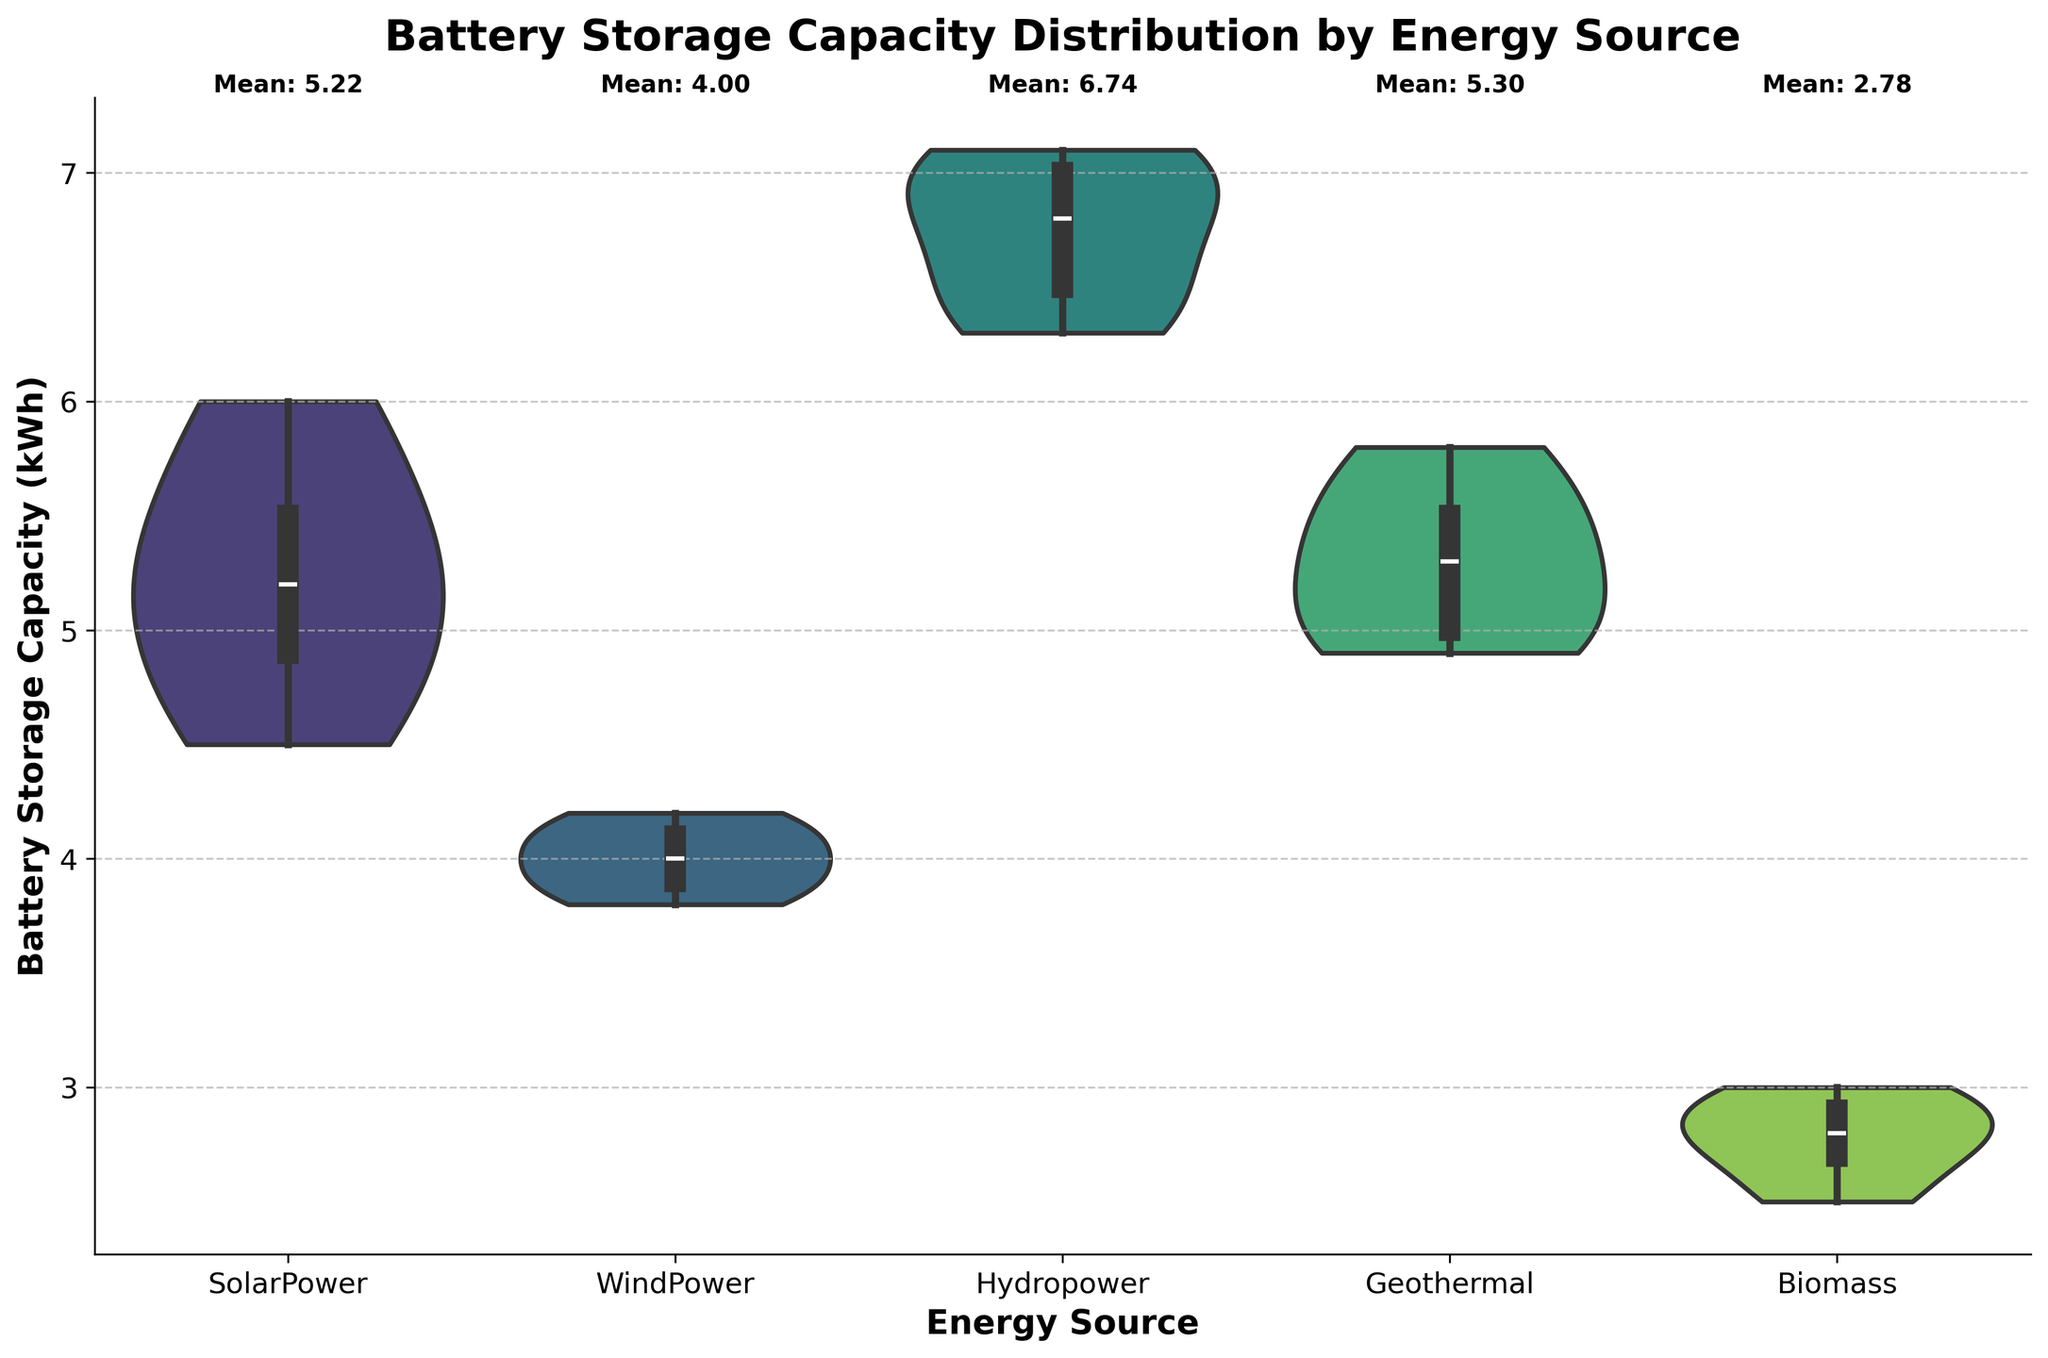What is the title of the figure? The title is usually located at the top center of the figure. For this figure, it reads "Battery Storage Capacity Distribution by Energy Source".
Answer: Battery Storage Capacity Distribution by Energy Source What is the y-axis label? The y-axis label is found on the left side of the figure, describing what is being measured. Here, it is labeled "Battery Storage Capacity (kWh)".
Answer: Battery Storage Capacity (kWh) How many energy sources are compared in the figure? You can count the unique categories on the x-axis to determine the number of energy sources. In this case, there are five distinct sources: SolarPower, WindPower, Hydropower, Geothermal, and Biomass.
Answer: Five Which energy source has the highest mean battery storage capacity? According to the textual annotations at the top of each violion plot, Hydropower has the highest mean value.
Answer: Hydropower Which energy source has the smallest spread in battery storage capacity? The energy source with the smallest spread will have the narrowest violin plot. Biomass has the narrowest spread among all the energy sources.
Answer: Biomass What is the approximate median battery storage capacity for SolarPower? The median is indicated by the white dot inside the violin plot. For SolarPower, this dot appears to be around 5 kWh.
Answer: ~5 kWh Compare the range of battery storage capacities between WindPower and Geothermal. The range is the difference between the maximum and minimum values. WindPower ranges from about 3.8 to 4.2 kWh, while Geothermal ranges from about 4.9 to 5.8 kWh.
Answer: WindPower: 3.8-4.2 kWh, Geothermal: 4.9-5.8 kWh How do the interquartile ranges (IQR) of SolarPower and Hydropower compare? The interquartile range is represented by the width of the middle of the violin plot. SolarPower has a middle width between ~4.8 to 5.5 kWh, while Hydropower spans from ~6.3 to 7.0 kWh.
Answer: SolarPower: ~4.8-5.5 kWh, Hydropower: ~6.3-7.0 kWh Which energy source shows the most symmetrical distribution of battery storage capacities? The most symmetrical violin plot indicates that the data is evenly distributed around the median. Hydropower appears to have the most symmetrical distribution.
Answer: Hydropower What conclusion can you draw about the diversity of battery storage capacities in residential areas across different energy sources? Energy sources like Biomass show very narrow distributions, indicating less diversity in battery capacities, while others like SolarPower and Geothermal show broader distributions, indicating more diversity.
Answer: Biomass: low diversity, SolarPower & Geothermal: higher diversity 